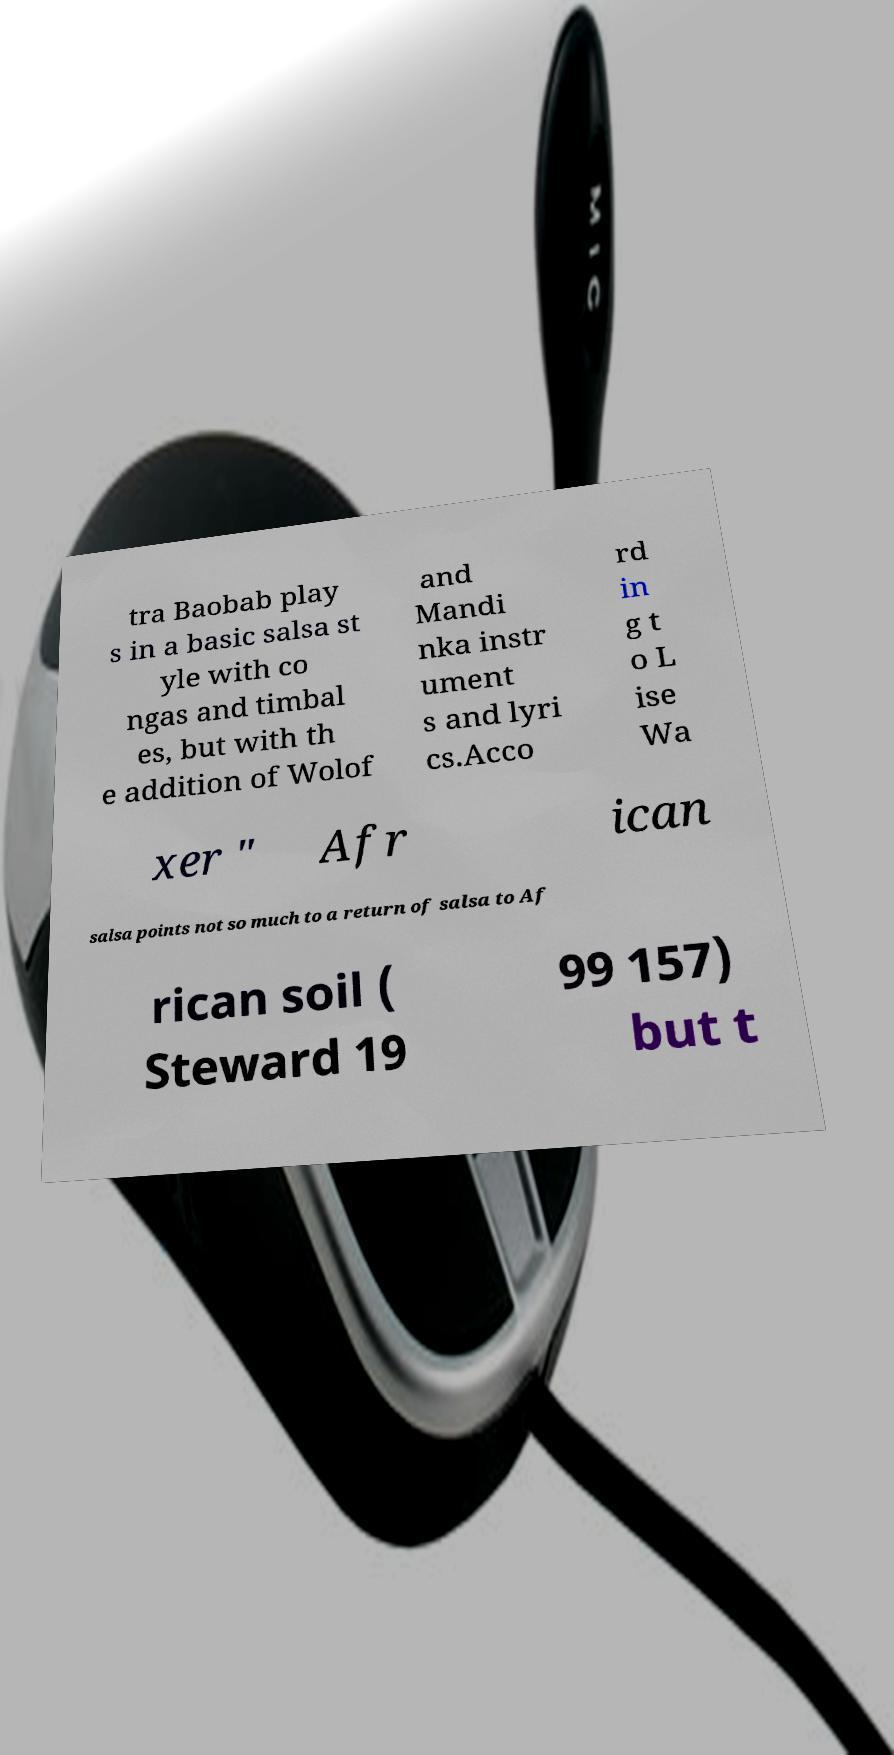Could you assist in decoding the text presented in this image and type it out clearly? tra Baobab play s in a basic salsa st yle with co ngas and timbal es, but with th e addition of Wolof and Mandi nka instr ument s and lyri cs.Acco rd in g t o L ise Wa xer " Afr ican salsa points not so much to a return of salsa to Af rican soil ( Steward 19 99 157) but t 